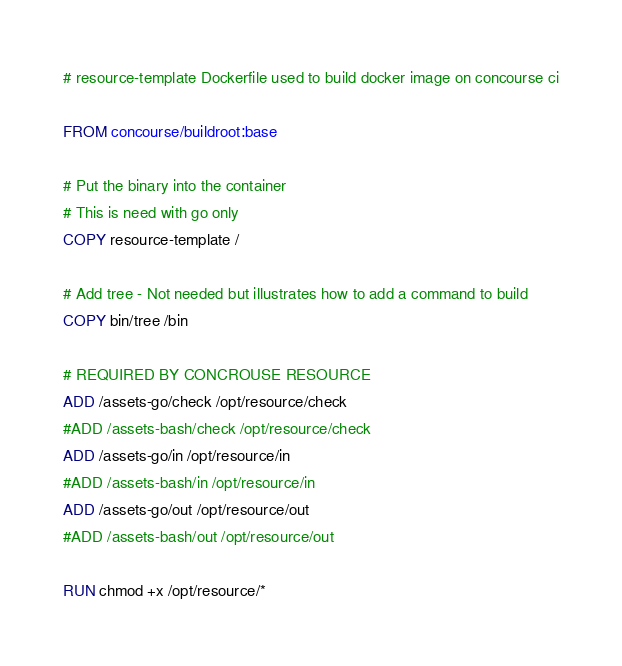Convert code to text. <code><loc_0><loc_0><loc_500><loc_500><_Dockerfile_># resource-template Dockerfile used to build docker image on concourse ci

FROM concourse/buildroot:base

# Put the binary into the container
# This is need with go only
COPY resource-template /

# Add tree - Not needed but illustrates how to add a command to build
COPY bin/tree /bin

# REQUIRED BY CONCROUSE RESOURCE
ADD /assets-go/check /opt/resource/check
#ADD /assets-bash/check /opt/resource/check
ADD /assets-go/in /opt/resource/in
#ADD /assets-bash/in /opt/resource/in
ADD /assets-go/out /opt/resource/out
#ADD /assets-bash/out /opt/resource/out

RUN chmod +x /opt/resource/*
</code> 